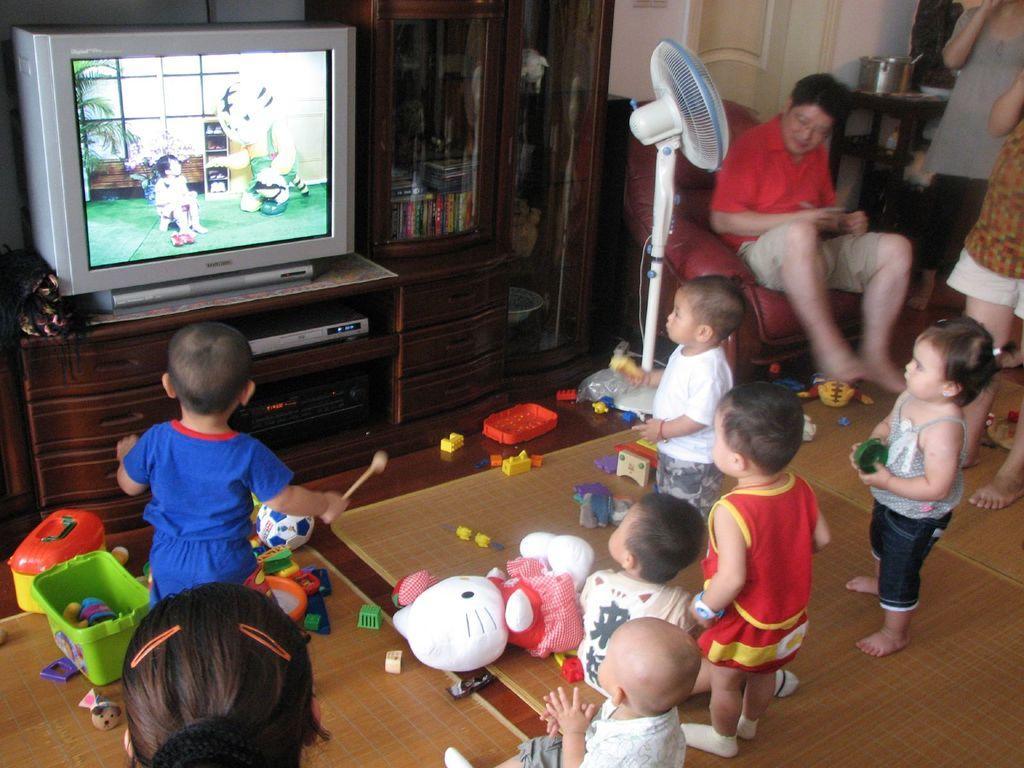Describe this image in one or two sentences. In this image, we can see people wearing clothes. There are some toys on the floor. There is a person on the right side of the image sitting on the couch. There is a fan in front of the cupboard. There is a drawer table and TV on the left side of the image. There are gadgets in the middle of the image. There is a stool and dish in the top right of the image. 